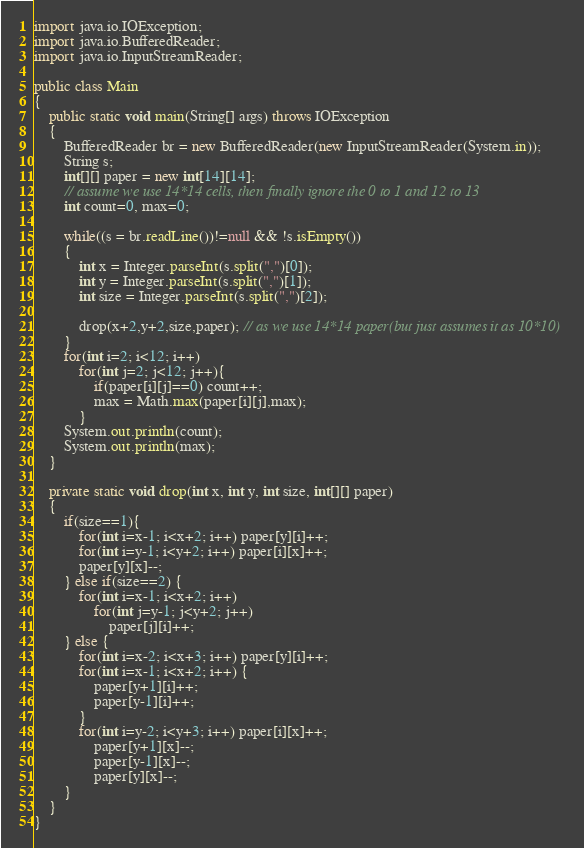Convert code to text. <code><loc_0><loc_0><loc_500><loc_500><_Java_>import java.io.IOException;
import java.io.BufferedReader;
import java.io.InputStreamReader;
 
public class Main
{
    public static void main(String[] args) throws IOException
    {
        BufferedReader br = new BufferedReader(new InputStreamReader(System.in));
        String s;
        int[][] paper = new int[14][14];
        // assume we use 14*14 cells, then finally ignore the 0 to 1 and 12 to 13
        int count=0, max=0;
         
        while((s = br.readLine())!=null && !s.isEmpty())
        {
            int x = Integer.parseInt(s.split(",")[0]);
            int y = Integer.parseInt(s.split(",")[1]);
            int size = Integer.parseInt(s.split(",")[2]);
             
            drop(x+2,y+2,size,paper); // as we use 14*14 paper(but just assumes it as 10*10)
        }
        for(int i=2; i<12; i++)
            for(int j=2; j<12; j++){
                if(paper[i][j]==0) count++;
                max = Math.max(paper[i][j],max);
            }
        System.out.println(count);
        System.out.println(max);
    }
         
    private static void drop(int x, int y, int size, int[][] paper)
    {
        if(size==1){
            for(int i=x-1; i<x+2; i++) paper[y][i]++;
            for(int i=y-1; i<y+2; i++) paper[i][x]++;
            paper[y][x]--;
        } else if(size==2) {
            for(int i=x-1; i<x+2; i++)
                for(int j=y-1; j<y+2; j++)
                    paper[j][i]++;
        } else {
            for(int i=x-2; i<x+3; i++) paper[y][i]++;
            for(int i=x-1; i<x+2; i++) {
                paper[y+1][i]++;
                paper[y-1][i]++;
            }
            for(int i=y-2; i<y+3; i++) paper[i][x]++;
                paper[y+1][x]--;
                paper[y-1][x]--;
                paper[y][x]--;
        }
    }
}</code> 